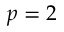<formula> <loc_0><loc_0><loc_500><loc_500>p = 2</formula> 